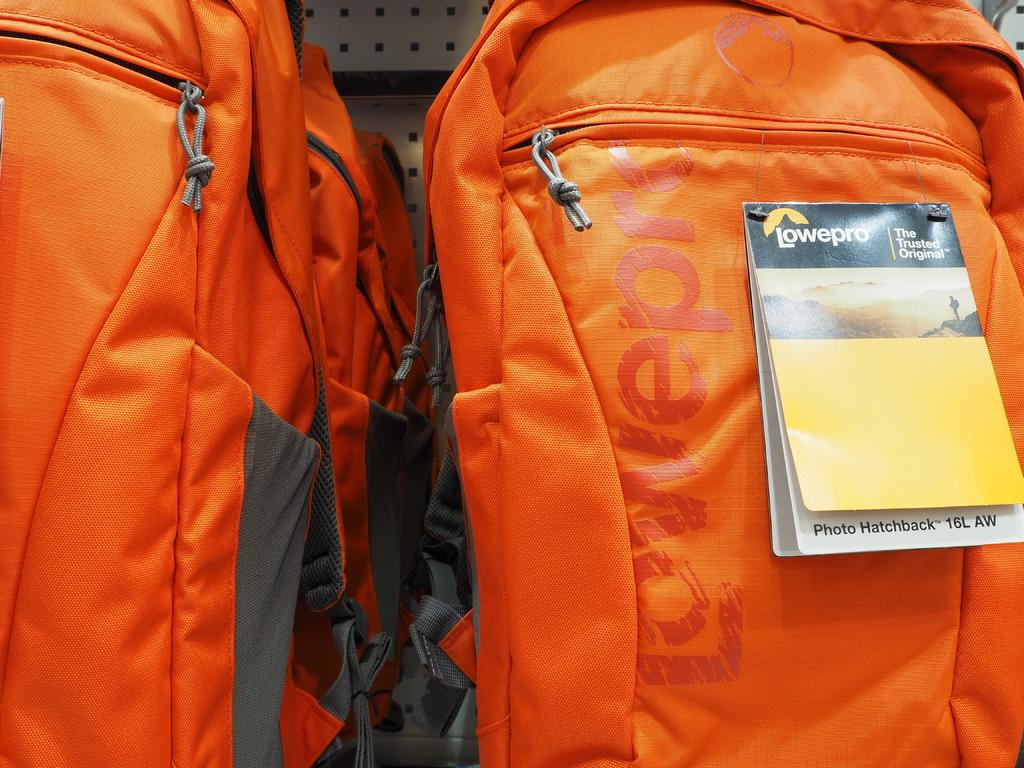What type of objects can be seen in the image? There are bags present in the image. Are the bags being used for a quiver in the image? There is no indication in the image that the bags are being used as a quiver. 